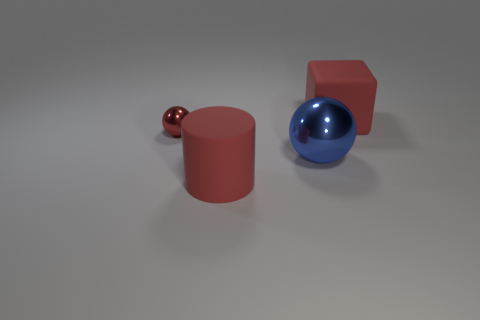Does the cylinder have the same size as the metal object that is behind the blue metallic sphere?
Provide a short and direct response. No. There is a metallic thing in front of the small red metal thing left of the rubber object behind the blue object; what size is it?
Your response must be concise. Large. There is a tiny red metallic object; is its shape the same as the metallic object that is on the right side of the big rubber cylinder?
Your response must be concise. Yes. What number of red objects are both on the right side of the rubber cylinder and in front of the large red block?
Ensure brevity in your answer.  0. How many gray objects are either rubber cubes or large balls?
Your response must be concise. 0. There is a big rubber thing behind the large blue thing; is its color the same as the shiny thing that is in front of the small red thing?
Your answer should be very brief. No. What is the color of the big sphere that is to the left of the matte thing behind the large matte thing that is in front of the large sphere?
Your response must be concise. Blue. Is there a red metal ball in front of the red thing behind the tiny red thing?
Keep it short and to the point. Yes. There is a red thing that is right of the big rubber cylinder; is its shape the same as the small object?
Provide a succinct answer. No. Is there any other thing that is the same shape as the large blue metal object?
Offer a terse response. Yes. 